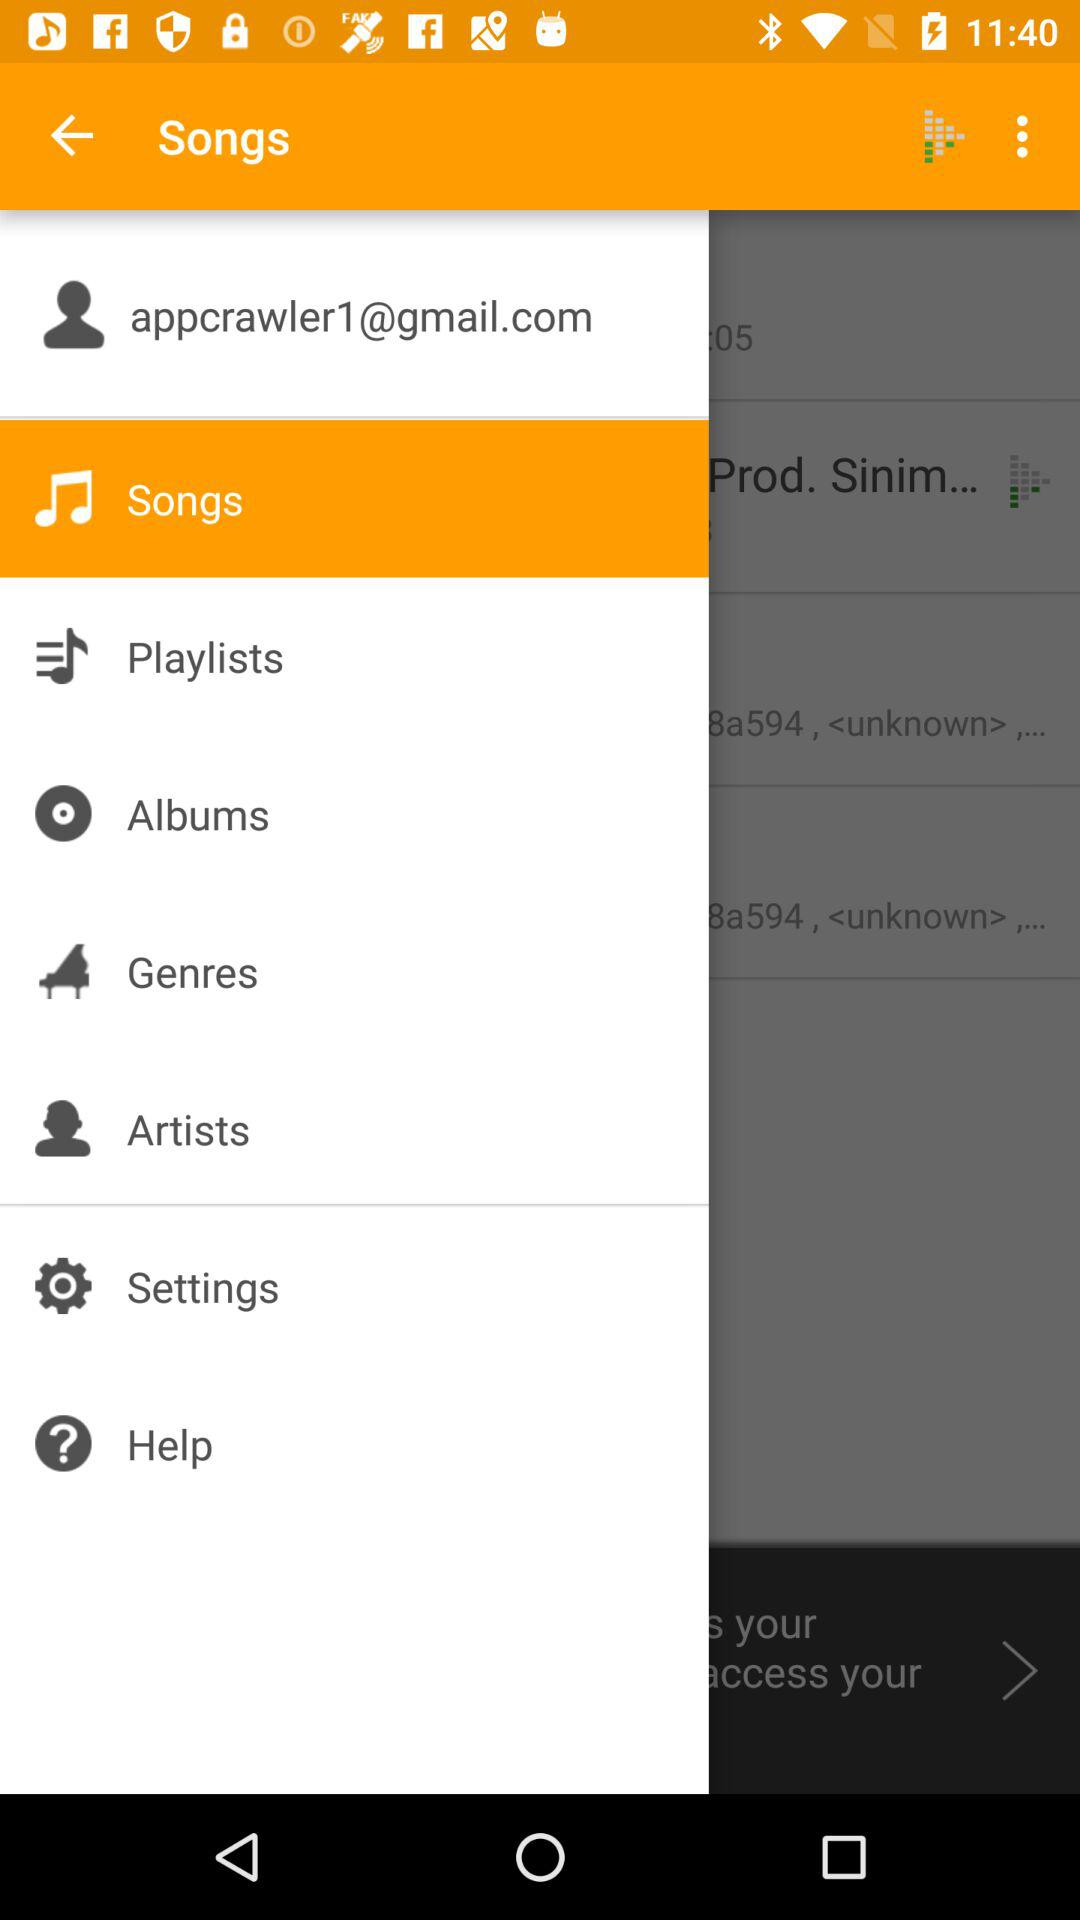What is the Gmail account address that is used? The used Gmail account address is appcrawler1@gmail.com. 